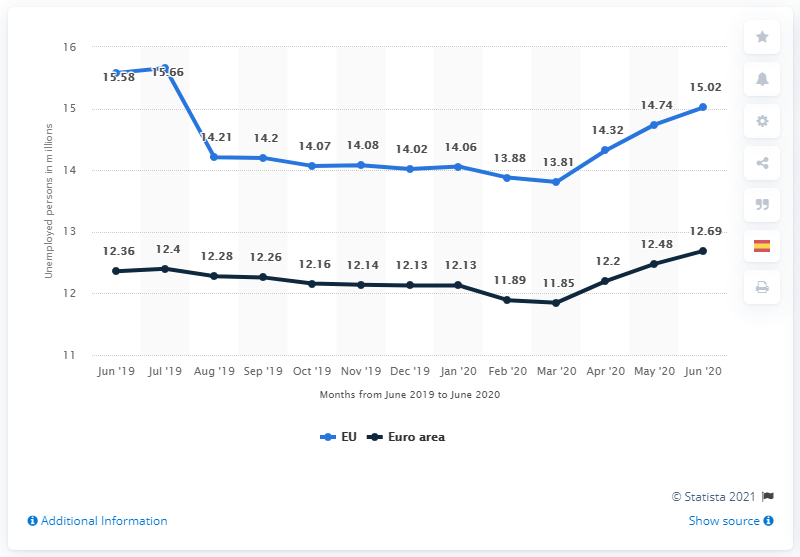Outline some significant characteristics in this image. In June 2020, there were approximately 15.02 million people in the European Union who were unemployed. 